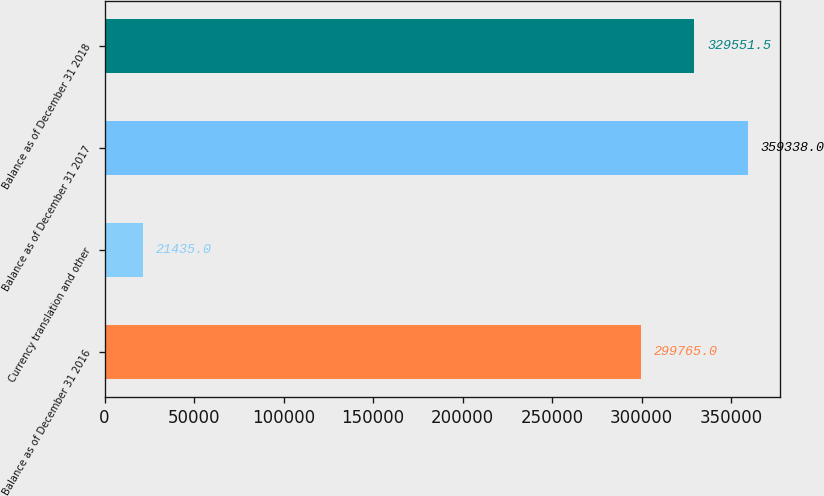Convert chart. <chart><loc_0><loc_0><loc_500><loc_500><bar_chart><fcel>Balance as of December 31 2016<fcel>Currency translation and other<fcel>Balance as of December 31 2017<fcel>Balance as of December 31 2018<nl><fcel>299765<fcel>21435<fcel>359338<fcel>329552<nl></chart> 